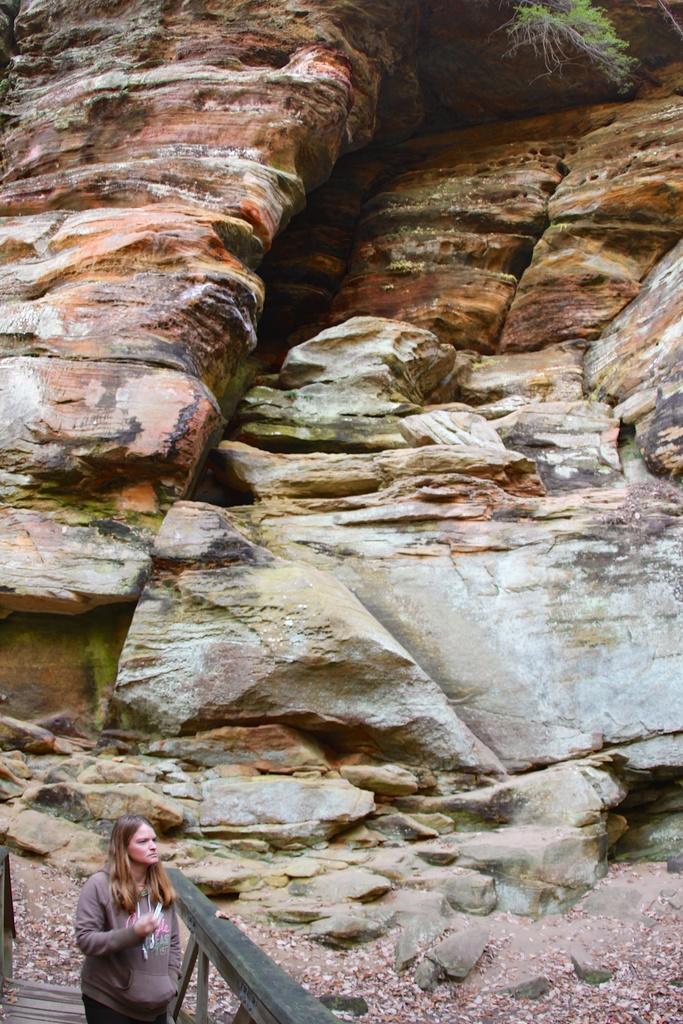In one or two sentences, can you explain what this image depicts? This image is taken outdoors. At the bottom of the image there is a ground with many dry leaves on it and a woman is standing on the wooden platform and there is a wooden railing. In the middle of the image there are a few rocks and at the top of the image there is a tree. 